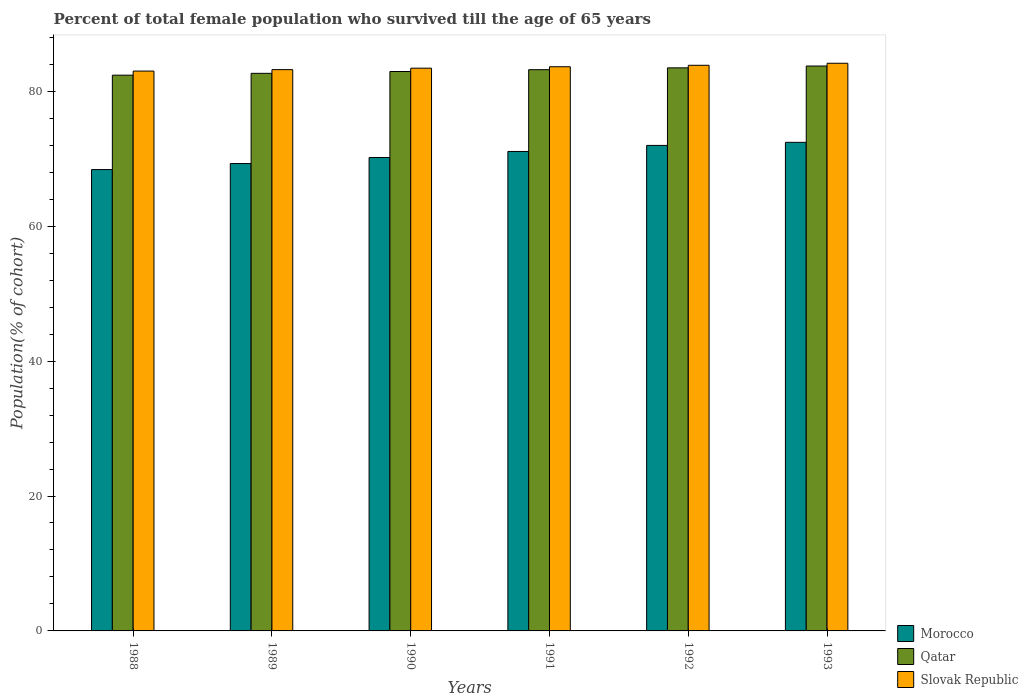Are the number of bars on each tick of the X-axis equal?
Ensure brevity in your answer.  Yes. How many bars are there on the 2nd tick from the left?
Your answer should be very brief. 3. What is the label of the 2nd group of bars from the left?
Your answer should be compact. 1989. In how many cases, is the number of bars for a given year not equal to the number of legend labels?
Provide a short and direct response. 0. What is the percentage of total female population who survived till the age of 65 years in Morocco in 1988?
Offer a very short reply. 68.39. Across all years, what is the maximum percentage of total female population who survived till the age of 65 years in Qatar?
Make the answer very short. 83.74. Across all years, what is the minimum percentage of total female population who survived till the age of 65 years in Qatar?
Offer a very short reply. 82.38. In which year was the percentage of total female population who survived till the age of 65 years in Morocco maximum?
Give a very brief answer. 1993. In which year was the percentage of total female population who survived till the age of 65 years in Morocco minimum?
Ensure brevity in your answer.  1988. What is the total percentage of total female population who survived till the age of 65 years in Slovak Republic in the graph?
Keep it short and to the point. 501.24. What is the difference between the percentage of total female population who survived till the age of 65 years in Qatar in 1990 and that in 1991?
Ensure brevity in your answer.  -0.27. What is the difference between the percentage of total female population who survived till the age of 65 years in Slovak Republic in 1991 and the percentage of total female population who survived till the age of 65 years in Qatar in 1990?
Your answer should be compact. 0.71. What is the average percentage of total female population who survived till the age of 65 years in Morocco per year?
Keep it short and to the point. 70.55. In the year 1993, what is the difference between the percentage of total female population who survived till the age of 65 years in Morocco and percentage of total female population who survived till the age of 65 years in Slovak Republic?
Ensure brevity in your answer.  -11.72. What is the ratio of the percentage of total female population who survived till the age of 65 years in Morocco in 1989 to that in 1993?
Offer a very short reply. 0.96. Is the difference between the percentage of total female population who survived till the age of 65 years in Morocco in 1992 and 1993 greater than the difference between the percentage of total female population who survived till the age of 65 years in Slovak Republic in 1992 and 1993?
Provide a short and direct response. No. What is the difference between the highest and the second highest percentage of total female population who survived till the age of 65 years in Morocco?
Your answer should be compact. 0.46. What is the difference between the highest and the lowest percentage of total female population who survived till the age of 65 years in Slovak Republic?
Your response must be concise. 1.16. In how many years, is the percentage of total female population who survived till the age of 65 years in Morocco greater than the average percentage of total female population who survived till the age of 65 years in Morocco taken over all years?
Give a very brief answer. 3. What does the 2nd bar from the left in 1988 represents?
Provide a succinct answer. Qatar. What does the 3rd bar from the right in 1988 represents?
Your answer should be compact. Morocco. Are all the bars in the graph horizontal?
Offer a terse response. No. How many years are there in the graph?
Give a very brief answer. 6. What is the difference between two consecutive major ticks on the Y-axis?
Your answer should be compact. 20. Does the graph contain any zero values?
Your response must be concise. No. Does the graph contain grids?
Ensure brevity in your answer.  No. Where does the legend appear in the graph?
Provide a succinct answer. Bottom right. How are the legend labels stacked?
Provide a succinct answer. Vertical. What is the title of the graph?
Your answer should be compact. Percent of total female population who survived till the age of 65 years. Does "New Zealand" appear as one of the legend labels in the graph?
Ensure brevity in your answer.  No. What is the label or title of the X-axis?
Keep it short and to the point. Years. What is the label or title of the Y-axis?
Your response must be concise. Population(% of cohort). What is the Population(% of cohort) of Morocco in 1988?
Offer a very short reply. 68.39. What is the Population(% of cohort) in Qatar in 1988?
Provide a succinct answer. 82.38. What is the Population(% of cohort) in Slovak Republic in 1988?
Provide a short and direct response. 82.99. What is the Population(% of cohort) of Morocco in 1989?
Ensure brevity in your answer.  69.28. What is the Population(% of cohort) of Qatar in 1989?
Give a very brief answer. 82.65. What is the Population(% of cohort) of Slovak Republic in 1989?
Provide a succinct answer. 83.2. What is the Population(% of cohort) in Morocco in 1990?
Ensure brevity in your answer.  70.18. What is the Population(% of cohort) in Qatar in 1990?
Give a very brief answer. 82.93. What is the Population(% of cohort) of Slovak Republic in 1990?
Offer a terse response. 83.42. What is the Population(% of cohort) in Morocco in 1991?
Keep it short and to the point. 71.07. What is the Population(% of cohort) of Qatar in 1991?
Offer a very short reply. 83.2. What is the Population(% of cohort) in Slovak Republic in 1991?
Ensure brevity in your answer.  83.63. What is the Population(% of cohort) in Morocco in 1992?
Make the answer very short. 71.97. What is the Population(% of cohort) of Qatar in 1992?
Your answer should be very brief. 83.47. What is the Population(% of cohort) of Slovak Republic in 1992?
Provide a short and direct response. 83.85. What is the Population(% of cohort) in Morocco in 1993?
Your answer should be very brief. 72.43. What is the Population(% of cohort) of Qatar in 1993?
Your answer should be very brief. 83.74. What is the Population(% of cohort) of Slovak Republic in 1993?
Provide a succinct answer. 84.15. Across all years, what is the maximum Population(% of cohort) in Morocco?
Your answer should be compact. 72.43. Across all years, what is the maximum Population(% of cohort) in Qatar?
Make the answer very short. 83.74. Across all years, what is the maximum Population(% of cohort) of Slovak Republic?
Provide a short and direct response. 84.15. Across all years, what is the minimum Population(% of cohort) in Morocco?
Offer a very short reply. 68.39. Across all years, what is the minimum Population(% of cohort) in Qatar?
Offer a terse response. 82.38. Across all years, what is the minimum Population(% of cohort) of Slovak Republic?
Provide a succinct answer. 82.99. What is the total Population(% of cohort) in Morocco in the graph?
Give a very brief answer. 423.32. What is the total Population(% of cohort) in Qatar in the graph?
Make the answer very short. 498.37. What is the total Population(% of cohort) in Slovak Republic in the graph?
Give a very brief answer. 501.24. What is the difference between the Population(% of cohort) of Morocco in 1988 and that in 1989?
Your response must be concise. -0.9. What is the difference between the Population(% of cohort) of Qatar in 1988 and that in 1989?
Provide a short and direct response. -0.27. What is the difference between the Population(% of cohort) of Slovak Republic in 1988 and that in 1989?
Offer a very short reply. -0.21. What is the difference between the Population(% of cohort) in Morocco in 1988 and that in 1990?
Ensure brevity in your answer.  -1.79. What is the difference between the Population(% of cohort) of Qatar in 1988 and that in 1990?
Offer a very short reply. -0.54. What is the difference between the Population(% of cohort) in Slovak Republic in 1988 and that in 1990?
Provide a succinct answer. -0.43. What is the difference between the Population(% of cohort) in Morocco in 1988 and that in 1991?
Offer a terse response. -2.69. What is the difference between the Population(% of cohort) in Qatar in 1988 and that in 1991?
Give a very brief answer. -0.81. What is the difference between the Population(% of cohort) of Slovak Republic in 1988 and that in 1991?
Provide a short and direct response. -0.64. What is the difference between the Population(% of cohort) in Morocco in 1988 and that in 1992?
Give a very brief answer. -3.58. What is the difference between the Population(% of cohort) of Qatar in 1988 and that in 1992?
Make the answer very short. -1.08. What is the difference between the Population(% of cohort) in Slovak Republic in 1988 and that in 1992?
Make the answer very short. -0.86. What is the difference between the Population(% of cohort) in Morocco in 1988 and that in 1993?
Your response must be concise. -4.04. What is the difference between the Population(% of cohort) of Qatar in 1988 and that in 1993?
Provide a succinct answer. -1.35. What is the difference between the Population(% of cohort) in Slovak Republic in 1988 and that in 1993?
Give a very brief answer. -1.16. What is the difference between the Population(% of cohort) in Morocco in 1989 and that in 1990?
Give a very brief answer. -0.9. What is the difference between the Population(% of cohort) in Qatar in 1989 and that in 1990?
Make the answer very short. -0.27. What is the difference between the Population(% of cohort) in Slovak Republic in 1989 and that in 1990?
Your answer should be compact. -0.21. What is the difference between the Population(% of cohort) in Morocco in 1989 and that in 1991?
Offer a very short reply. -1.79. What is the difference between the Population(% of cohort) in Qatar in 1989 and that in 1991?
Give a very brief answer. -0.54. What is the difference between the Population(% of cohort) of Slovak Republic in 1989 and that in 1991?
Provide a short and direct response. -0.43. What is the difference between the Population(% of cohort) in Morocco in 1989 and that in 1992?
Ensure brevity in your answer.  -2.69. What is the difference between the Population(% of cohort) of Qatar in 1989 and that in 1992?
Make the answer very short. -0.81. What is the difference between the Population(% of cohort) in Slovak Republic in 1989 and that in 1992?
Your answer should be compact. -0.64. What is the difference between the Population(% of cohort) of Morocco in 1989 and that in 1993?
Keep it short and to the point. -3.14. What is the difference between the Population(% of cohort) in Qatar in 1989 and that in 1993?
Make the answer very short. -1.08. What is the difference between the Population(% of cohort) of Slovak Republic in 1989 and that in 1993?
Your response must be concise. -0.94. What is the difference between the Population(% of cohort) in Morocco in 1990 and that in 1991?
Offer a terse response. -0.9. What is the difference between the Population(% of cohort) of Qatar in 1990 and that in 1991?
Your answer should be very brief. -0.27. What is the difference between the Population(% of cohort) in Slovak Republic in 1990 and that in 1991?
Your answer should be compact. -0.21. What is the difference between the Population(% of cohort) in Morocco in 1990 and that in 1992?
Provide a succinct answer. -1.79. What is the difference between the Population(% of cohort) in Qatar in 1990 and that in 1992?
Your answer should be compact. -0.54. What is the difference between the Population(% of cohort) in Slovak Republic in 1990 and that in 1992?
Your answer should be very brief. -0.43. What is the difference between the Population(% of cohort) in Morocco in 1990 and that in 1993?
Your answer should be compact. -2.25. What is the difference between the Population(% of cohort) in Qatar in 1990 and that in 1993?
Provide a succinct answer. -0.81. What is the difference between the Population(% of cohort) of Slovak Republic in 1990 and that in 1993?
Offer a very short reply. -0.73. What is the difference between the Population(% of cohort) of Morocco in 1991 and that in 1992?
Your response must be concise. -0.9. What is the difference between the Population(% of cohort) in Qatar in 1991 and that in 1992?
Your response must be concise. -0.27. What is the difference between the Population(% of cohort) in Slovak Republic in 1991 and that in 1992?
Provide a short and direct response. -0.21. What is the difference between the Population(% of cohort) of Morocco in 1991 and that in 1993?
Offer a very short reply. -1.35. What is the difference between the Population(% of cohort) of Qatar in 1991 and that in 1993?
Make the answer very short. -0.54. What is the difference between the Population(% of cohort) in Slovak Republic in 1991 and that in 1993?
Keep it short and to the point. -0.52. What is the difference between the Population(% of cohort) in Morocco in 1992 and that in 1993?
Give a very brief answer. -0.46. What is the difference between the Population(% of cohort) in Qatar in 1992 and that in 1993?
Your response must be concise. -0.27. What is the difference between the Population(% of cohort) of Slovak Republic in 1992 and that in 1993?
Your answer should be compact. -0.3. What is the difference between the Population(% of cohort) in Morocco in 1988 and the Population(% of cohort) in Qatar in 1989?
Your answer should be compact. -14.27. What is the difference between the Population(% of cohort) of Morocco in 1988 and the Population(% of cohort) of Slovak Republic in 1989?
Your answer should be compact. -14.82. What is the difference between the Population(% of cohort) of Qatar in 1988 and the Population(% of cohort) of Slovak Republic in 1989?
Your response must be concise. -0.82. What is the difference between the Population(% of cohort) in Morocco in 1988 and the Population(% of cohort) in Qatar in 1990?
Provide a short and direct response. -14.54. What is the difference between the Population(% of cohort) of Morocco in 1988 and the Population(% of cohort) of Slovak Republic in 1990?
Provide a succinct answer. -15.03. What is the difference between the Population(% of cohort) of Qatar in 1988 and the Population(% of cohort) of Slovak Republic in 1990?
Provide a short and direct response. -1.03. What is the difference between the Population(% of cohort) of Morocco in 1988 and the Population(% of cohort) of Qatar in 1991?
Your answer should be very brief. -14.81. What is the difference between the Population(% of cohort) in Morocco in 1988 and the Population(% of cohort) in Slovak Republic in 1991?
Provide a short and direct response. -15.24. What is the difference between the Population(% of cohort) of Qatar in 1988 and the Population(% of cohort) of Slovak Republic in 1991?
Your answer should be compact. -1.25. What is the difference between the Population(% of cohort) of Morocco in 1988 and the Population(% of cohort) of Qatar in 1992?
Offer a very short reply. -15.08. What is the difference between the Population(% of cohort) in Morocco in 1988 and the Population(% of cohort) in Slovak Republic in 1992?
Keep it short and to the point. -15.46. What is the difference between the Population(% of cohort) in Qatar in 1988 and the Population(% of cohort) in Slovak Republic in 1992?
Your answer should be very brief. -1.46. What is the difference between the Population(% of cohort) of Morocco in 1988 and the Population(% of cohort) of Qatar in 1993?
Provide a short and direct response. -15.35. What is the difference between the Population(% of cohort) in Morocco in 1988 and the Population(% of cohort) in Slovak Republic in 1993?
Your answer should be compact. -15.76. What is the difference between the Population(% of cohort) in Qatar in 1988 and the Population(% of cohort) in Slovak Republic in 1993?
Make the answer very short. -1.76. What is the difference between the Population(% of cohort) in Morocco in 1989 and the Population(% of cohort) in Qatar in 1990?
Your response must be concise. -13.64. What is the difference between the Population(% of cohort) of Morocco in 1989 and the Population(% of cohort) of Slovak Republic in 1990?
Your answer should be very brief. -14.13. What is the difference between the Population(% of cohort) in Qatar in 1989 and the Population(% of cohort) in Slovak Republic in 1990?
Keep it short and to the point. -0.76. What is the difference between the Population(% of cohort) of Morocco in 1989 and the Population(% of cohort) of Qatar in 1991?
Your answer should be very brief. -13.91. What is the difference between the Population(% of cohort) of Morocco in 1989 and the Population(% of cohort) of Slovak Republic in 1991?
Your answer should be compact. -14.35. What is the difference between the Population(% of cohort) of Qatar in 1989 and the Population(% of cohort) of Slovak Republic in 1991?
Offer a very short reply. -0.98. What is the difference between the Population(% of cohort) in Morocco in 1989 and the Population(% of cohort) in Qatar in 1992?
Offer a very short reply. -14.18. What is the difference between the Population(% of cohort) in Morocco in 1989 and the Population(% of cohort) in Slovak Republic in 1992?
Ensure brevity in your answer.  -14.56. What is the difference between the Population(% of cohort) in Qatar in 1989 and the Population(% of cohort) in Slovak Republic in 1992?
Make the answer very short. -1.19. What is the difference between the Population(% of cohort) in Morocco in 1989 and the Population(% of cohort) in Qatar in 1993?
Your answer should be compact. -14.45. What is the difference between the Population(% of cohort) in Morocco in 1989 and the Population(% of cohort) in Slovak Republic in 1993?
Your response must be concise. -14.86. What is the difference between the Population(% of cohort) of Qatar in 1989 and the Population(% of cohort) of Slovak Republic in 1993?
Make the answer very short. -1.49. What is the difference between the Population(% of cohort) in Morocco in 1990 and the Population(% of cohort) in Qatar in 1991?
Give a very brief answer. -13.02. What is the difference between the Population(% of cohort) of Morocco in 1990 and the Population(% of cohort) of Slovak Republic in 1991?
Make the answer very short. -13.45. What is the difference between the Population(% of cohort) in Qatar in 1990 and the Population(% of cohort) in Slovak Republic in 1991?
Offer a terse response. -0.71. What is the difference between the Population(% of cohort) of Morocco in 1990 and the Population(% of cohort) of Qatar in 1992?
Your answer should be very brief. -13.29. What is the difference between the Population(% of cohort) of Morocco in 1990 and the Population(% of cohort) of Slovak Republic in 1992?
Ensure brevity in your answer.  -13.67. What is the difference between the Population(% of cohort) of Qatar in 1990 and the Population(% of cohort) of Slovak Republic in 1992?
Ensure brevity in your answer.  -0.92. What is the difference between the Population(% of cohort) of Morocco in 1990 and the Population(% of cohort) of Qatar in 1993?
Your response must be concise. -13.56. What is the difference between the Population(% of cohort) of Morocco in 1990 and the Population(% of cohort) of Slovak Republic in 1993?
Provide a short and direct response. -13.97. What is the difference between the Population(% of cohort) in Qatar in 1990 and the Population(% of cohort) in Slovak Republic in 1993?
Make the answer very short. -1.22. What is the difference between the Population(% of cohort) in Morocco in 1991 and the Population(% of cohort) in Qatar in 1992?
Ensure brevity in your answer.  -12.39. What is the difference between the Population(% of cohort) of Morocco in 1991 and the Population(% of cohort) of Slovak Republic in 1992?
Give a very brief answer. -12.77. What is the difference between the Population(% of cohort) in Qatar in 1991 and the Population(% of cohort) in Slovak Republic in 1992?
Provide a succinct answer. -0.65. What is the difference between the Population(% of cohort) of Morocco in 1991 and the Population(% of cohort) of Qatar in 1993?
Your answer should be very brief. -12.66. What is the difference between the Population(% of cohort) of Morocco in 1991 and the Population(% of cohort) of Slovak Republic in 1993?
Keep it short and to the point. -13.07. What is the difference between the Population(% of cohort) in Qatar in 1991 and the Population(% of cohort) in Slovak Republic in 1993?
Make the answer very short. -0.95. What is the difference between the Population(% of cohort) in Morocco in 1992 and the Population(% of cohort) in Qatar in 1993?
Offer a terse response. -11.77. What is the difference between the Population(% of cohort) of Morocco in 1992 and the Population(% of cohort) of Slovak Republic in 1993?
Make the answer very short. -12.18. What is the difference between the Population(% of cohort) of Qatar in 1992 and the Population(% of cohort) of Slovak Republic in 1993?
Provide a succinct answer. -0.68. What is the average Population(% of cohort) of Morocco per year?
Make the answer very short. 70.55. What is the average Population(% of cohort) in Qatar per year?
Ensure brevity in your answer.  83.06. What is the average Population(% of cohort) in Slovak Republic per year?
Ensure brevity in your answer.  83.54. In the year 1988, what is the difference between the Population(% of cohort) in Morocco and Population(% of cohort) in Qatar?
Give a very brief answer. -14. In the year 1988, what is the difference between the Population(% of cohort) in Morocco and Population(% of cohort) in Slovak Republic?
Give a very brief answer. -14.6. In the year 1988, what is the difference between the Population(% of cohort) of Qatar and Population(% of cohort) of Slovak Republic?
Your answer should be compact. -0.61. In the year 1989, what is the difference between the Population(% of cohort) in Morocco and Population(% of cohort) in Qatar?
Offer a very short reply. -13.37. In the year 1989, what is the difference between the Population(% of cohort) in Morocco and Population(% of cohort) in Slovak Republic?
Ensure brevity in your answer.  -13.92. In the year 1989, what is the difference between the Population(% of cohort) in Qatar and Population(% of cohort) in Slovak Republic?
Offer a very short reply. -0.55. In the year 1990, what is the difference between the Population(% of cohort) in Morocco and Population(% of cohort) in Qatar?
Provide a short and direct response. -12.75. In the year 1990, what is the difference between the Population(% of cohort) of Morocco and Population(% of cohort) of Slovak Republic?
Ensure brevity in your answer.  -13.24. In the year 1990, what is the difference between the Population(% of cohort) in Qatar and Population(% of cohort) in Slovak Republic?
Make the answer very short. -0.49. In the year 1991, what is the difference between the Population(% of cohort) of Morocco and Population(% of cohort) of Qatar?
Provide a short and direct response. -12.12. In the year 1991, what is the difference between the Population(% of cohort) in Morocco and Population(% of cohort) in Slovak Republic?
Your response must be concise. -12.56. In the year 1991, what is the difference between the Population(% of cohort) of Qatar and Population(% of cohort) of Slovak Republic?
Your response must be concise. -0.44. In the year 1992, what is the difference between the Population(% of cohort) of Morocco and Population(% of cohort) of Qatar?
Offer a very short reply. -11.5. In the year 1992, what is the difference between the Population(% of cohort) of Morocco and Population(% of cohort) of Slovak Republic?
Your answer should be very brief. -11.88. In the year 1992, what is the difference between the Population(% of cohort) in Qatar and Population(% of cohort) in Slovak Republic?
Provide a short and direct response. -0.38. In the year 1993, what is the difference between the Population(% of cohort) of Morocco and Population(% of cohort) of Qatar?
Provide a succinct answer. -11.31. In the year 1993, what is the difference between the Population(% of cohort) of Morocco and Population(% of cohort) of Slovak Republic?
Provide a short and direct response. -11.72. In the year 1993, what is the difference between the Population(% of cohort) of Qatar and Population(% of cohort) of Slovak Republic?
Keep it short and to the point. -0.41. What is the ratio of the Population(% of cohort) of Morocco in 1988 to that in 1989?
Ensure brevity in your answer.  0.99. What is the ratio of the Population(% of cohort) in Morocco in 1988 to that in 1990?
Provide a short and direct response. 0.97. What is the ratio of the Population(% of cohort) in Qatar in 1988 to that in 1990?
Give a very brief answer. 0.99. What is the ratio of the Population(% of cohort) of Morocco in 1988 to that in 1991?
Ensure brevity in your answer.  0.96. What is the ratio of the Population(% of cohort) in Qatar in 1988 to that in 1991?
Your answer should be very brief. 0.99. What is the ratio of the Population(% of cohort) in Morocco in 1988 to that in 1992?
Your response must be concise. 0.95. What is the ratio of the Population(% of cohort) of Morocco in 1988 to that in 1993?
Provide a succinct answer. 0.94. What is the ratio of the Population(% of cohort) of Qatar in 1988 to that in 1993?
Give a very brief answer. 0.98. What is the ratio of the Population(% of cohort) in Slovak Republic in 1988 to that in 1993?
Provide a succinct answer. 0.99. What is the ratio of the Population(% of cohort) of Morocco in 1989 to that in 1990?
Your answer should be compact. 0.99. What is the ratio of the Population(% of cohort) in Qatar in 1989 to that in 1990?
Your answer should be compact. 1. What is the ratio of the Population(% of cohort) of Morocco in 1989 to that in 1991?
Offer a terse response. 0.97. What is the ratio of the Population(% of cohort) in Morocco in 1989 to that in 1992?
Provide a short and direct response. 0.96. What is the ratio of the Population(% of cohort) of Qatar in 1989 to that in 1992?
Offer a very short reply. 0.99. What is the ratio of the Population(% of cohort) in Slovak Republic in 1989 to that in 1992?
Your answer should be compact. 0.99. What is the ratio of the Population(% of cohort) in Morocco in 1989 to that in 1993?
Offer a terse response. 0.96. What is the ratio of the Population(% of cohort) in Qatar in 1989 to that in 1993?
Provide a short and direct response. 0.99. What is the ratio of the Population(% of cohort) of Morocco in 1990 to that in 1991?
Make the answer very short. 0.99. What is the ratio of the Population(% of cohort) of Qatar in 1990 to that in 1991?
Ensure brevity in your answer.  1. What is the ratio of the Population(% of cohort) of Morocco in 1990 to that in 1992?
Provide a succinct answer. 0.98. What is the ratio of the Population(% of cohort) in Qatar in 1990 to that in 1992?
Ensure brevity in your answer.  0.99. What is the ratio of the Population(% of cohort) of Morocco in 1990 to that in 1993?
Keep it short and to the point. 0.97. What is the ratio of the Population(% of cohort) in Qatar in 1990 to that in 1993?
Your response must be concise. 0.99. What is the ratio of the Population(% of cohort) in Morocco in 1991 to that in 1992?
Your answer should be very brief. 0.99. What is the ratio of the Population(% of cohort) in Qatar in 1991 to that in 1992?
Your answer should be very brief. 1. What is the ratio of the Population(% of cohort) of Slovak Republic in 1991 to that in 1992?
Provide a short and direct response. 1. What is the ratio of the Population(% of cohort) of Morocco in 1991 to that in 1993?
Keep it short and to the point. 0.98. What is the ratio of the Population(% of cohort) of Morocco in 1992 to that in 1993?
Your answer should be very brief. 0.99. What is the ratio of the Population(% of cohort) of Qatar in 1992 to that in 1993?
Offer a terse response. 1. What is the difference between the highest and the second highest Population(% of cohort) in Morocco?
Provide a short and direct response. 0.46. What is the difference between the highest and the second highest Population(% of cohort) in Qatar?
Provide a short and direct response. 0.27. What is the difference between the highest and the second highest Population(% of cohort) of Slovak Republic?
Your response must be concise. 0.3. What is the difference between the highest and the lowest Population(% of cohort) in Morocco?
Keep it short and to the point. 4.04. What is the difference between the highest and the lowest Population(% of cohort) of Qatar?
Make the answer very short. 1.35. What is the difference between the highest and the lowest Population(% of cohort) of Slovak Republic?
Keep it short and to the point. 1.16. 